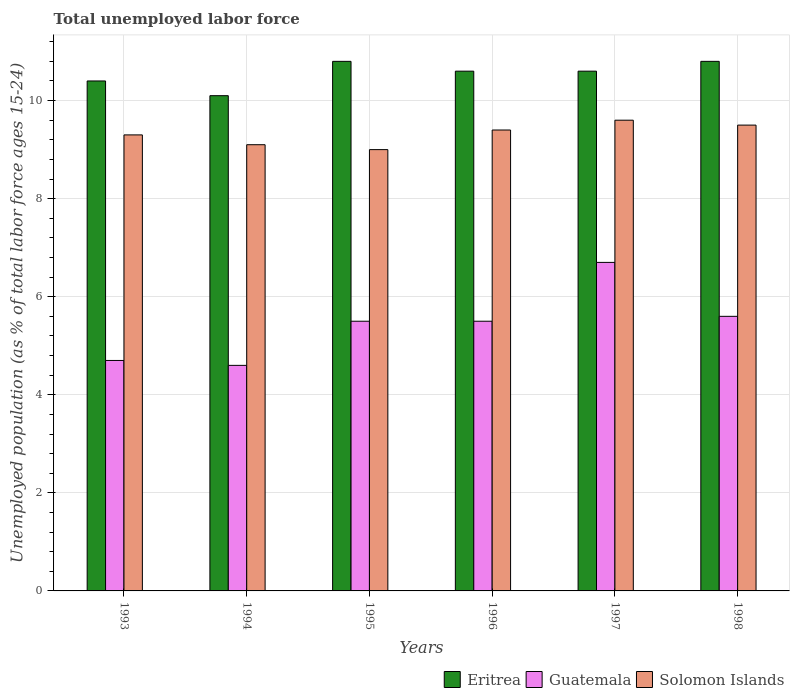How many different coloured bars are there?
Your answer should be compact. 3. How many groups of bars are there?
Make the answer very short. 6. Are the number of bars per tick equal to the number of legend labels?
Offer a terse response. Yes. Are the number of bars on each tick of the X-axis equal?
Provide a succinct answer. Yes. What is the label of the 3rd group of bars from the left?
Your response must be concise. 1995. What is the percentage of unemployed population in in Guatemala in 1996?
Give a very brief answer. 5.5. Across all years, what is the maximum percentage of unemployed population in in Eritrea?
Make the answer very short. 10.8. Across all years, what is the minimum percentage of unemployed population in in Solomon Islands?
Ensure brevity in your answer.  9. In which year was the percentage of unemployed population in in Guatemala maximum?
Your answer should be very brief. 1997. In which year was the percentage of unemployed population in in Eritrea minimum?
Offer a terse response. 1994. What is the total percentage of unemployed population in in Eritrea in the graph?
Make the answer very short. 63.3. What is the difference between the percentage of unemployed population in in Eritrea in 1993 and that in 1996?
Your response must be concise. -0.2. What is the difference between the percentage of unemployed population in in Eritrea in 1997 and the percentage of unemployed population in in Solomon Islands in 1994?
Offer a terse response. 1.5. What is the average percentage of unemployed population in in Eritrea per year?
Provide a succinct answer. 10.55. In the year 1995, what is the difference between the percentage of unemployed population in in Guatemala and percentage of unemployed population in in Eritrea?
Your answer should be compact. -5.3. In how many years, is the percentage of unemployed population in in Solomon Islands greater than 6.8 %?
Offer a terse response. 6. What is the ratio of the percentage of unemployed population in in Guatemala in 1993 to that in 1995?
Your answer should be compact. 0.85. Is the percentage of unemployed population in in Solomon Islands in 1996 less than that in 1997?
Your response must be concise. Yes. Is the difference between the percentage of unemployed population in in Guatemala in 1994 and 1997 greater than the difference between the percentage of unemployed population in in Eritrea in 1994 and 1997?
Provide a short and direct response. No. What is the difference between the highest and the second highest percentage of unemployed population in in Solomon Islands?
Keep it short and to the point. 0.1. What is the difference between the highest and the lowest percentage of unemployed population in in Solomon Islands?
Offer a terse response. 0.6. In how many years, is the percentage of unemployed population in in Solomon Islands greater than the average percentage of unemployed population in in Solomon Islands taken over all years?
Your answer should be very brief. 3. Is the sum of the percentage of unemployed population in in Solomon Islands in 1996 and 1997 greater than the maximum percentage of unemployed population in in Guatemala across all years?
Your response must be concise. Yes. What does the 3rd bar from the left in 1993 represents?
Your response must be concise. Solomon Islands. What does the 2nd bar from the right in 1998 represents?
Offer a very short reply. Guatemala. How many bars are there?
Provide a succinct answer. 18. How many years are there in the graph?
Make the answer very short. 6. Does the graph contain any zero values?
Your response must be concise. No. Does the graph contain grids?
Provide a short and direct response. Yes. How many legend labels are there?
Offer a terse response. 3. What is the title of the graph?
Offer a very short reply. Total unemployed labor force. What is the label or title of the Y-axis?
Ensure brevity in your answer.  Unemployed population (as % of total labor force ages 15-24). What is the Unemployed population (as % of total labor force ages 15-24) in Eritrea in 1993?
Provide a succinct answer. 10.4. What is the Unemployed population (as % of total labor force ages 15-24) of Guatemala in 1993?
Your answer should be compact. 4.7. What is the Unemployed population (as % of total labor force ages 15-24) of Solomon Islands in 1993?
Provide a short and direct response. 9.3. What is the Unemployed population (as % of total labor force ages 15-24) in Eritrea in 1994?
Give a very brief answer. 10.1. What is the Unemployed population (as % of total labor force ages 15-24) in Guatemala in 1994?
Provide a succinct answer. 4.6. What is the Unemployed population (as % of total labor force ages 15-24) in Solomon Islands in 1994?
Provide a succinct answer. 9.1. What is the Unemployed population (as % of total labor force ages 15-24) of Eritrea in 1995?
Give a very brief answer. 10.8. What is the Unemployed population (as % of total labor force ages 15-24) of Eritrea in 1996?
Make the answer very short. 10.6. What is the Unemployed population (as % of total labor force ages 15-24) in Solomon Islands in 1996?
Keep it short and to the point. 9.4. What is the Unemployed population (as % of total labor force ages 15-24) in Eritrea in 1997?
Keep it short and to the point. 10.6. What is the Unemployed population (as % of total labor force ages 15-24) of Guatemala in 1997?
Your response must be concise. 6.7. What is the Unemployed population (as % of total labor force ages 15-24) in Solomon Islands in 1997?
Ensure brevity in your answer.  9.6. What is the Unemployed population (as % of total labor force ages 15-24) in Eritrea in 1998?
Make the answer very short. 10.8. What is the Unemployed population (as % of total labor force ages 15-24) of Guatemala in 1998?
Your answer should be compact. 5.6. What is the Unemployed population (as % of total labor force ages 15-24) of Solomon Islands in 1998?
Provide a succinct answer. 9.5. Across all years, what is the maximum Unemployed population (as % of total labor force ages 15-24) of Eritrea?
Keep it short and to the point. 10.8. Across all years, what is the maximum Unemployed population (as % of total labor force ages 15-24) in Guatemala?
Your response must be concise. 6.7. Across all years, what is the maximum Unemployed population (as % of total labor force ages 15-24) of Solomon Islands?
Offer a very short reply. 9.6. Across all years, what is the minimum Unemployed population (as % of total labor force ages 15-24) in Eritrea?
Your response must be concise. 10.1. Across all years, what is the minimum Unemployed population (as % of total labor force ages 15-24) of Guatemala?
Make the answer very short. 4.6. What is the total Unemployed population (as % of total labor force ages 15-24) in Eritrea in the graph?
Give a very brief answer. 63.3. What is the total Unemployed population (as % of total labor force ages 15-24) in Guatemala in the graph?
Your response must be concise. 32.6. What is the total Unemployed population (as % of total labor force ages 15-24) of Solomon Islands in the graph?
Your answer should be compact. 55.9. What is the difference between the Unemployed population (as % of total labor force ages 15-24) of Guatemala in 1993 and that in 1994?
Make the answer very short. 0.1. What is the difference between the Unemployed population (as % of total labor force ages 15-24) in Solomon Islands in 1993 and that in 1995?
Make the answer very short. 0.3. What is the difference between the Unemployed population (as % of total labor force ages 15-24) in Eritrea in 1993 and that in 1996?
Offer a terse response. -0.2. What is the difference between the Unemployed population (as % of total labor force ages 15-24) in Solomon Islands in 1993 and that in 1996?
Provide a short and direct response. -0.1. What is the difference between the Unemployed population (as % of total labor force ages 15-24) of Solomon Islands in 1993 and that in 1997?
Ensure brevity in your answer.  -0.3. What is the difference between the Unemployed population (as % of total labor force ages 15-24) of Eritrea in 1993 and that in 1998?
Offer a very short reply. -0.4. What is the difference between the Unemployed population (as % of total labor force ages 15-24) of Guatemala in 1993 and that in 1998?
Your answer should be compact. -0.9. What is the difference between the Unemployed population (as % of total labor force ages 15-24) in Solomon Islands in 1993 and that in 1998?
Ensure brevity in your answer.  -0.2. What is the difference between the Unemployed population (as % of total labor force ages 15-24) of Solomon Islands in 1994 and that in 1995?
Provide a succinct answer. 0.1. What is the difference between the Unemployed population (as % of total labor force ages 15-24) of Guatemala in 1994 and that in 1996?
Keep it short and to the point. -0.9. What is the difference between the Unemployed population (as % of total labor force ages 15-24) of Eritrea in 1994 and that in 1997?
Your answer should be very brief. -0.5. What is the difference between the Unemployed population (as % of total labor force ages 15-24) in Solomon Islands in 1994 and that in 1997?
Ensure brevity in your answer.  -0.5. What is the difference between the Unemployed population (as % of total labor force ages 15-24) of Solomon Islands in 1994 and that in 1998?
Make the answer very short. -0.4. What is the difference between the Unemployed population (as % of total labor force ages 15-24) in Eritrea in 1995 and that in 1996?
Give a very brief answer. 0.2. What is the difference between the Unemployed population (as % of total labor force ages 15-24) in Guatemala in 1995 and that in 1998?
Keep it short and to the point. -0.1. What is the difference between the Unemployed population (as % of total labor force ages 15-24) of Guatemala in 1996 and that in 1997?
Give a very brief answer. -1.2. What is the difference between the Unemployed population (as % of total labor force ages 15-24) of Solomon Islands in 1996 and that in 1997?
Make the answer very short. -0.2. What is the difference between the Unemployed population (as % of total labor force ages 15-24) in Eritrea in 1996 and that in 1998?
Keep it short and to the point. -0.2. What is the difference between the Unemployed population (as % of total labor force ages 15-24) in Guatemala in 1996 and that in 1998?
Keep it short and to the point. -0.1. What is the difference between the Unemployed population (as % of total labor force ages 15-24) in Solomon Islands in 1996 and that in 1998?
Make the answer very short. -0.1. What is the difference between the Unemployed population (as % of total labor force ages 15-24) of Eritrea in 1997 and that in 1998?
Offer a very short reply. -0.2. What is the difference between the Unemployed population (as % of total labor force ages 15-24) in Eritrea in 1993 and the Unemployed population (as % of total labor force ages 15-24) in Guatemala in 1994?
Keep it short and to the point. 5.8. What is the difference between the Unemployed population (as % of total labor force ages 15-24) of Eritrea in 1993 and the Unemployed population (as % of total labor force ages 15-24) of Solomon Islands in 1994?
Offer a terse response. 1.3. What is the difference between the Unemployed population (as % of total labor force ages 15-24) in Eritrea in 1993 and the Unemployed population (as % of total labor force ages 15-24) in Guatemala in 1996?
Make the answer very short. 4.9. What is the difference between the Unemployed population (as % of total labor force ages 15-24) in Eritrea in 1993 and the Unemployed population (as % of total labor force ages 15-24) in Guatemala in 1997?
Ensure brevity in your answer.  3.7. What is the difference between the Unemployed population (as % of total labor force ages 15-24) of Eritrea in 1993 and the Unemployed population (as % of total labor force ages 15-24) of Guatemala in 1998?
Give a very brief answer. 4.8. What is the difference between the Unemployed population (as % of total labor force ages 15-24) in Eritrea in 1994 and the Unemployed population (as % of total labor force ages 15-24) in Solomon Islands in 1995?
Offer a terse response. 1.1. What is the difference between the Unemployed population (as % of total labor force ages 15-24) of Eritrea in 1994 and the Unemployed population (as % of total labor force ages 15-24) of Guatemala in 1996?
Your answer should be very brief. 4.6. What is the difference between the Unemployed population (as % of total labor force ages 15-24) in Eritrea in 1994 and the Unemployed population (as % of total labor force ages 15-24) in Solomon Islands in 1996?
Offer a very short reply. 0.7. What is the difference between the Unemployed population (as % of total labor force ages 15-24) of Eritrea in 1994 and the Unemployed population (as % of total labor force ages 15-24) of Guatemala in 1997?
Keep it short and to the point. 3.4. What is the difference between the Unemployed population (as % of total labor force ages 15-24) of Eritrea in 1995 and the Unemployed population (as % of total labor force ages 15-24) of Guatemala in 1997?
Your response must be concise. 4.1. What is the difference between the Unemployed population (as % of total labor force ages 15-24) of Eritrea in 1995 and the Unemployed population (as % of total labor force ages 15-24) of Solomon Islands in 1997?
Your response must be concise. 1.2. What is the difference between the Unemployed population (as % of total labor force ages 15-24) in Eritrea in 1996 and the Unemployed population (as % of total labor force ages 15-24) in Solomon Islands in 1997?
Offer a very short reply. 1. What is the difference between the Unemployed population (as % of total labor force ages 15-24) of Guatemala in 1996 and the Unemployed population (as % of total labor force ages 15-24) of Solomon Islands in 1997?
Offer a terse response. -4.1. What is the difference between the Unemployed population (as % of total labor force ages 15-24) in Eritrea in 1996 and the Unemployed population (as % of total labor force ages 15-24) in Guatemala in 1998?
Give a very brief answer. 5. What is the difference between the Unemployed population (as % of total labor force ages 15-24) in Eritrea in 1996 and the Unemployed population (as % of total labor force ages 15-24) in Solomon Islands in 1998?
Offer a terse response. 1.1. What is the difference between the Unemployed population (as % of total labor force ages 15-24) in Eritrea in 1997 and the Unemployed population (as % of total labor force ages 15-24) in Guatemala in 1998?
Your answer should be very brief. 5. What is the difference between the Unemployed population (as % of total labor force ages 15-24) in Guatemala in 1997 and the Unemployed population (as % of total labor force ages 15-24) in Solomon Islands in 1998?
Your response must be concise. -2.8. What is the average Unemployed population (as % of total labor force ages 15-24) of Eritrea per year?
Ensure brevity in your answer.  10.55. What is the average Unemployed population (as % of total labor force ages 15-24) of Guatemala per year?
Make the answer very short. 5.43. What is the average Unemployed population (as % of total labor force ages 15-24) of Solomon Islands per year?
Provide a succinct answer. 9.32. In the year 1993, what is the difference between the Unemployed population (as % of total labor force ages 15-24) in Eritrea and Unemployed population (as % of total labor force ages 15-24) in Guatemala?
Your answer should be compact. 5.7. In the year 1993, what is the difference between the Unemployed population (as % of total labor force ages 15-24) in Guatemala and Unemployed population (as % of total labor force ages 15-24) in Solomon Islands?
Keep it short and to the point. -4.6. In the year 1994, what is the difference between the Unemployed population (as % of total labor force ages 15-24) in Eritrea and Unemployed population (as % of total labor force ages 15-24) in Solomon Islands?
Offer a terse response. 1. In the year 1994, what is the difference between the Unemployed population (as % of total labor force ages 15-24) of Guatemala and Unemployed population (as % of total labor force ages 15-24) of Solomon Islands?
Your response must be concise. -4.5. In the year 1995, what is the difference between the Unemployed population (as % of total labor force ages 15-24) of Eritrea and Unemployed population (as % of total labor force ages 15-24) of Solomon Islands?
Make the answer very short. 1.8. In the year 1995, what is the difference between the Unemployed population (as % of total labor force ages 15-24) of Guatemala and Unemployed population (as % of total labor force ages 15-24) of Solomon Islands?
Ensure brevity in your answer.  -3.5. In the year 1996, what is the difference between the Unemployed population (as % of total labor force ages 15-24) of Eritrea and Unemployed population (as % of total labor force ages 15-24) of Solomon Islands?
Provide a short and direct response. 1.2. In the year 1996, what is the difference between the Unemployed population (as % of total labor force ages 15-24) of Guatemala and Unemployed population (as % of total labor force ages 15-24) of Solomon Islands?
Provide a short and direct response. -3.9. In the year 1997, what is the difference between the Unemployed population (as % of total labor force ages 15-24) of Eritrea and Unemployed population (as % of total labor force ages 15-24) of Solomon Islands?
Provide a short and direct response. 1. In the year 1998, what is the difference between the Unemployed population (as % of total labor force ages 15-24) of Eritrea and Unemployed population (as % of total labor force ages 15-24) of Guatemala?
Your response must be concise. 5.2. In the year 1998, what is the difference between the Unemployed population (as % of total labor force ages 15-24) in Guatemala and Unemployed population (as % of total labor force ages 15-24) in Solomon Islands?
Provide a succinct answer. -3.9. What is the ratio of the Unemployed population (as % of total labor force ages 15-24) of Eritrea in 1993 to that in 1994?
Your answer should be very brief. 1.03. What is the ratio of the Unemployed population (as % of total labor force ages 15-24) of Guatemala in 1993 to that in 1994?
Your response must be concise. 1.02. What is the ratio of the Unemployed population (as % of total labor force ages 15-24) in Solomon Islands in 1993 to that in 1994?
Make the answer very short. 1.02. What is the ratio of the Unemployed population (as % of total labor force ages 15-24) of Guatemala in 1993 to that in 1995?
Your response must be concise. 0.85. What is the ratio of the Unemployed population (as % of total labor force ages 15-24) of Eritrea in 1993 to that in 1996?
Keep it short and to the point. 0.98. What is the ratio of the Unemployed population (as % of total labor force ages 15-24) in Guatemala in 1993 to that in 1996?
Your answer should be very brief. 0.85. What is the ratio of the Unemployed population (as % of total labor force ages 15-24) in Eritrea in 1993 to that in 1997?
Offer a very short reply. 0.98. What is the ratio of the Unemployed population (as % of total labor force ages 15-24) of Guatemala in 1993 to that in 1997?
Offer a very short reply. 0.7. What is the ratio of the Unemployed population (as % of total labor force ages 15-24) in Solomon Islands in 1993 to that in 1997?
Provide a succinct answer. 0.97. What is the ratio of the Unemployed population (as % of total labor force ages 15-24) in Guatemala in 1993 to that in 1998?
Keep it short and to the point. 0.84. What is the ratio of the Unemployed population (as % of total labor force ages 15-24) in Solomon Islands in 1993 to that in 1998?
Your response must be concise. 0.98. What is the ratio of the Unemployed population (as % of total labor force ages 15-24) of Eritrea in 1994 to that in 1995?
Your answer should be compact. 0.94. What is the ratio of the Unemployed population (as % of total labor force ages 15-24) of Guatemala in 1994 to that in 1995?
Offer a very short reply. 0.84. What is the ratio of the Unemployed population (as % of total labor force ages 15-24) of Solomon Islands in 1994 to that in 1995?
Offer a terse response. 1.01. What is the ratio of the Unemployed population (as % of total labor force ages 15-24) in Eritrea in 1994 to that in 1996?
Provide a short and direct response. 0.95. What is the ratio of the Unemployed population (as % of total labor force ages 15-24) of Guatemala in 1994 to that in 1996?
Keep it short and to the point. 0.84. What is the ratio of the Unemployed population (as % of total labor force ages 15-24) of Solomon Islands in 1994 to that in 1996?
Your answer should be very brief. 0.97. What is the ratio of the Unemployed population (as % of total labor force ages 15-24) of Eritrea in 1994 to that in 1997?
Your answer should be very brief. 0.95. What is the ratio of the Unemployed population (as % of total labor force ages 15-24) in Guatemala in 1994 to that in 1997?
Provide a succinct answer. 0.69. What is the ratio of the Unemployed population (as % of total labor force ages 15-24) in Solomon Islands in 1994 to that in 1997?
Make the answer very short. 0.95. What is the ratio of the Unemployed population (as % of total labor force ages 15-24) of Eritrea in 1994 to that in 1998?
Provide a succinct answer. 0.94. What is the ratio of the Unemployed population (as % of total labor force ages 15-24) of Guatemala in 1994 to that in 1998?
Make the answer very short. 0.82. What is the ratio of the Unemployed population (as % of total labor force ages 15-24) of Solomon Islands in 1994 to that in 1998?
Your response must be concise. 0.96. What is the ratio of the Unemployed population (as % of total labor force ages 15-24) in Eritrea in 1995 to that in 1996?
Your answer should be very brief. 1.02. What is the ratio of the Unemployed population (as % of total labor force ages 15-24) of Solomon Islands in 1995 to that in 1996?
Provide a short and direct response. 0.96. What is the ratio of the Unemployed population (as % of total labor force ages 15-24) of Eritrea in 1995 to that in 1997?
Offer a terse response. 1.02. What is the ratio of the Unemployed population (as % of total labor force ages 15-24) in Guatemala in 1995 to that in 1997?
Provide a succinct answer. 0.82. What is the ratio of the Unemployed population (as % of total labor force ages 15-24) of Solomon Islands in 1995 to that in 1997?
Your answer should be compact. 0.94. What is the ratio of the Unemployed population (as % of total labor force ages 15-24) of Guatemala in 1995 to that in 1998?
Keep it short and to the point. 0.98. What is the ratio of the Unemployed population (as % of total labor force ages 15-24) of Solomon Islands in 1995 to that in 1998?
Provide a short and direct response. 0.95. What is the ratio of the Unemployed population (as % of total labor force ages 15-24) in Guatemala in 1996 to that in 1997?
Ensure brevity in your answer.  0.82. What is the ratio of the Unemployed population (as % of total labor force ages 15-24) in Solomon Islands in 1996 to that in 1997?
Ensure brevity in your answer.  0.98. What is the ratio of the Unemployed population (as % of total labor force ages 15-24) of Eritrea in 1996 to that in 1998?
Provide a short and direct response. 0.98. What is the ratio of the Unemployed population (as % of total labor force ages 15-24) in Guatemala in 1996 to that in 1998?
Ensure brevity in your answer.  0.98. What is the ratio of the Unemployed population (as % of total labor force ages 15-24) in Eritrea in 1997 to that in 1998?
Ensure brevity in your answer.  0.98. What is the ratio of the Unemployed population (as % of total labor force ages 15-24) in Guatemala in 1997 to that in 1998?
Offer a terse response. 1.2. What is the ratio of the Unemployed population (as % of total labor force ages 15-24) of Solomon Islands in 1997 to that in 1998?
Make the answer very short. 1.01. What is the difference between the highest and the second highest Unemployed population (as % of total labor force ages 15-24) in Eritrea?
Offer a terse response. 0. What is the difference between the highest and the second highest Unemployed population (as % of total labor force ages 15-24) of Guatemala?
Your answer should be very brief. 1.1. What is the difference between the highest and the second highest Unemployed population (as % of total labor force ages 15-24) of Solomon Islands?
Ensure brevity in your answer.  0.1. What is the difference between the highest and the lowest Unemployed population (as % of total labor force ages 15-24) in Eritrea?
Make the answer very short. 0.7. What is the difference between the highest and the lowest Unemployed population (as % of total labor force ages 15-24) of Guatemala?
Offer a terse response. 2.1. What is the difference between the highest and the lowest Unemployed population (as % of total labor force ages 15-24) of Solomon Islands?
Your answer should be compact. 0.6. 